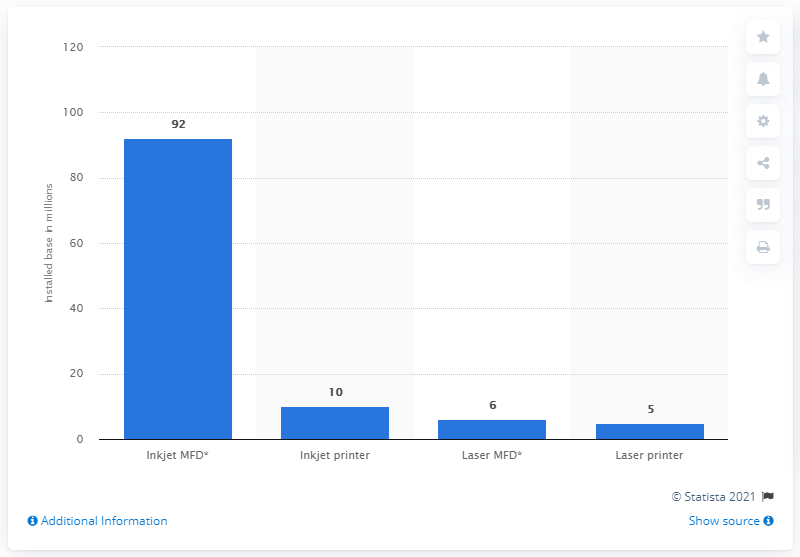Draw attention to some important aspects in this diagram. In 2010, approximately 10 inkjet printers were installed in the United States. 